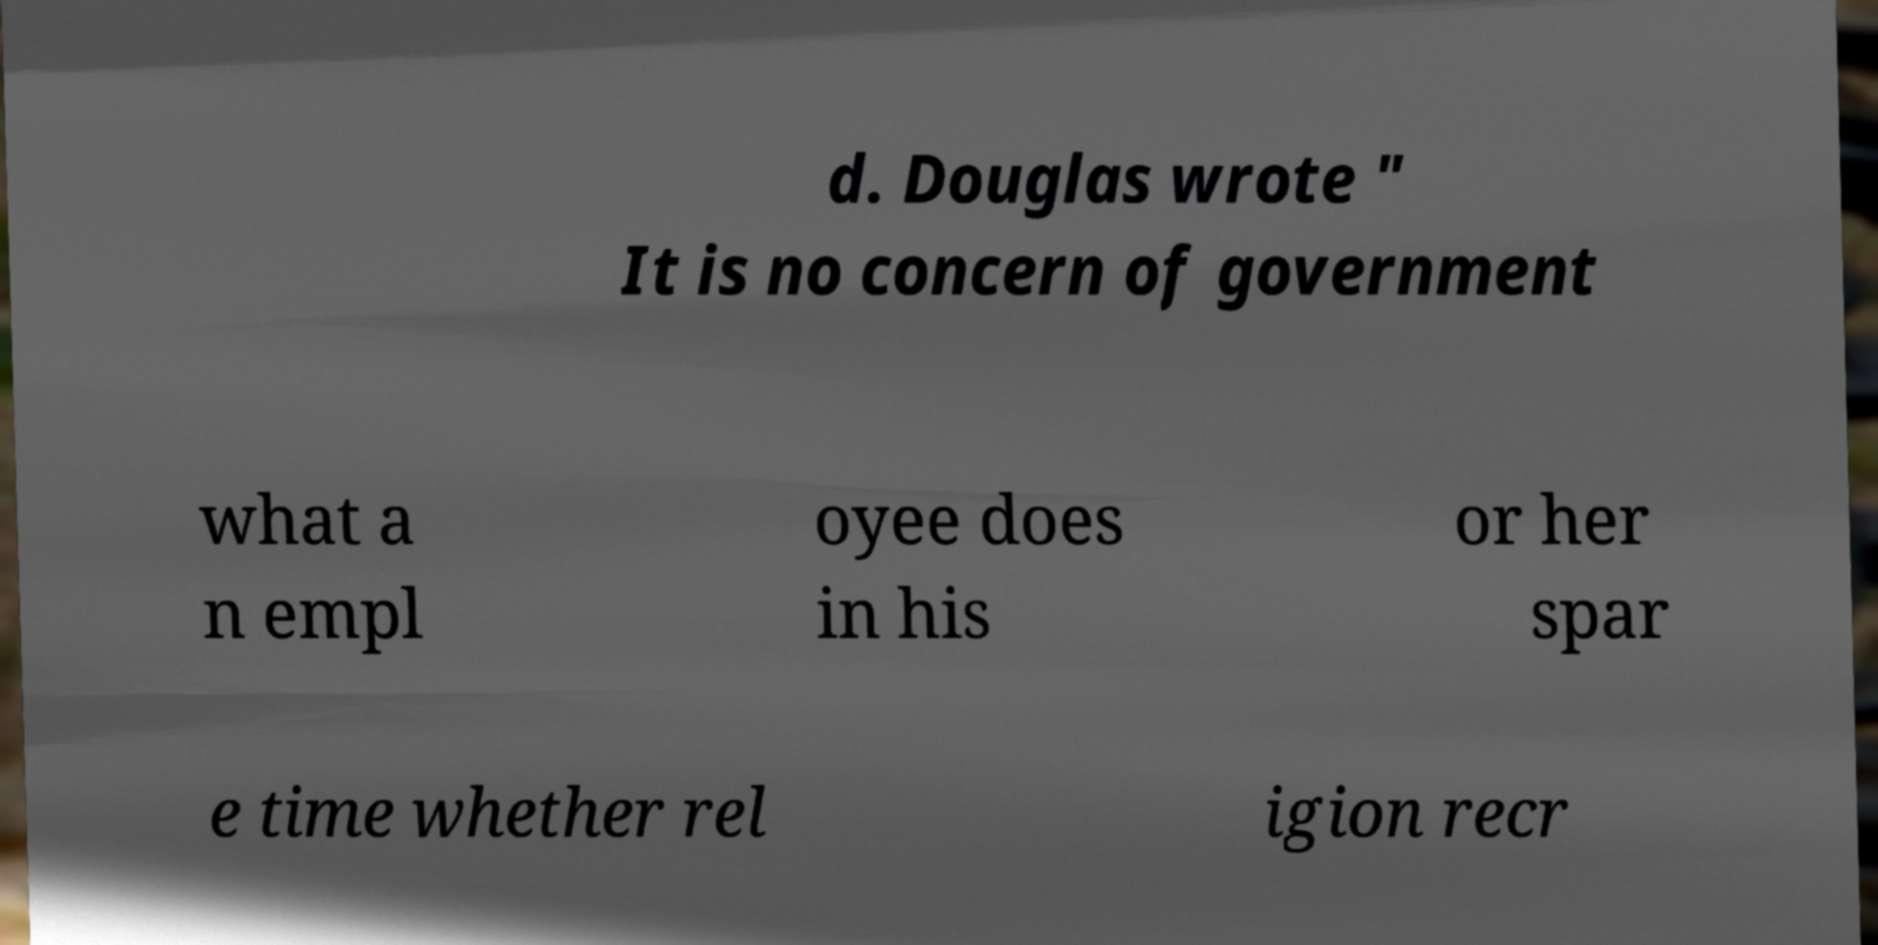Please read and relay the text visible in this image. What does it say? d. Douglas wrote " It is no concern of government what a n empl oyee does in his or her spar e time whether rel igion recr 